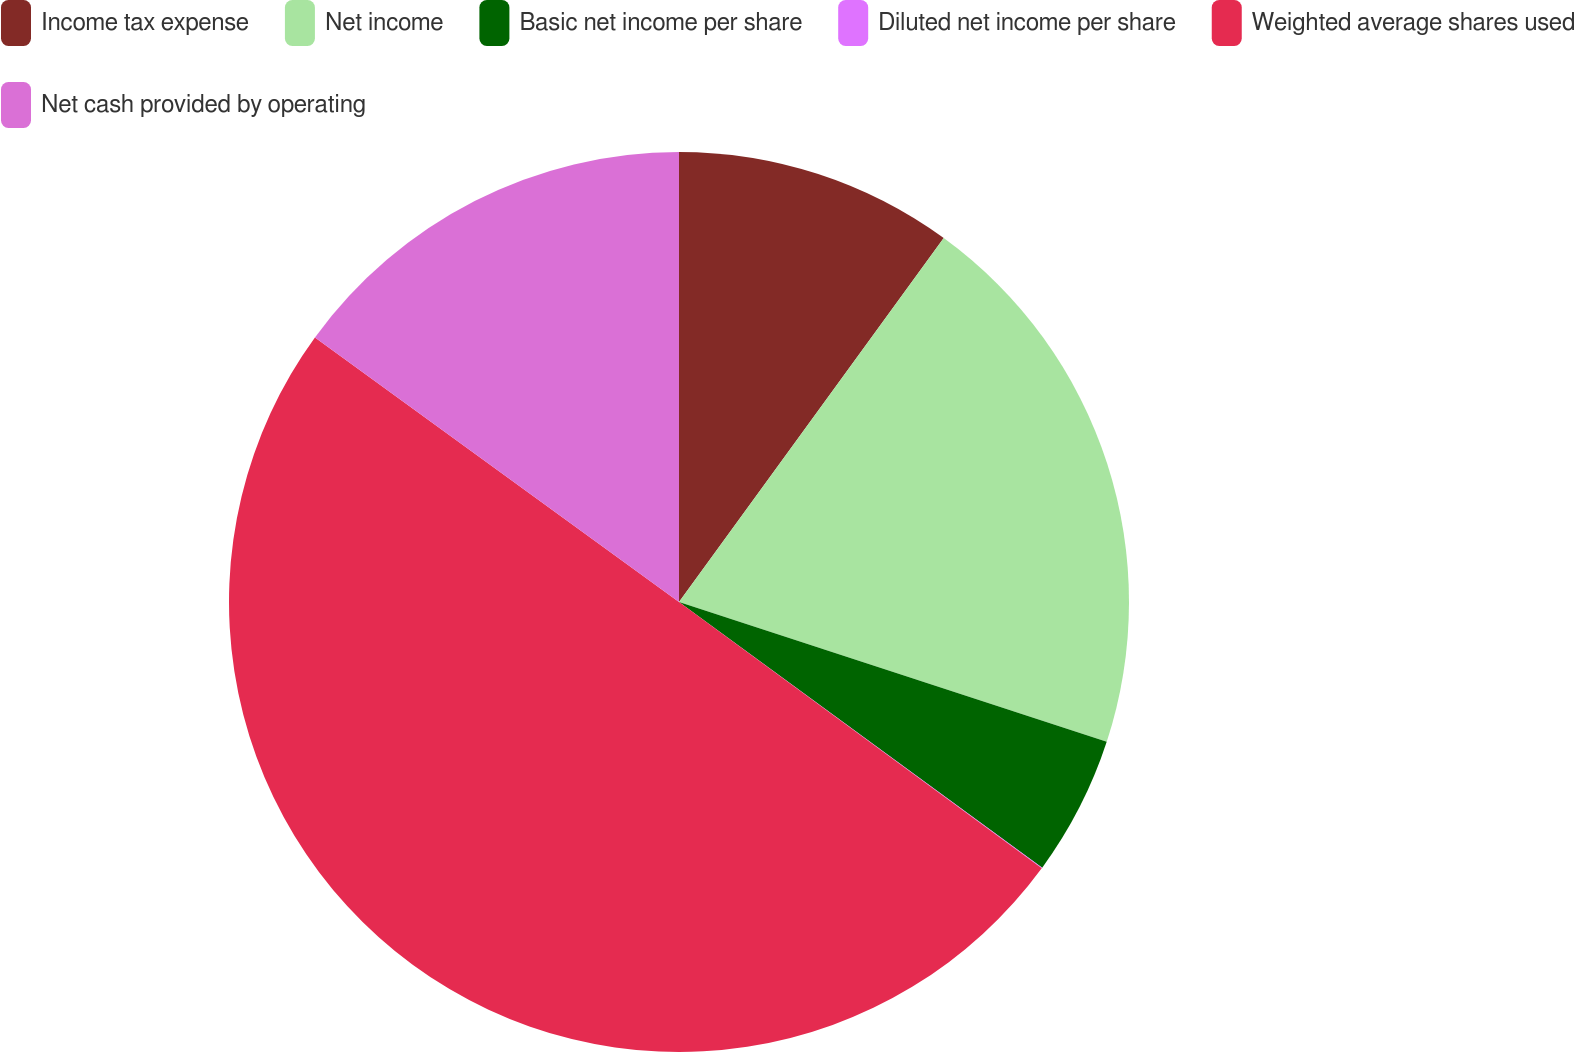Convert chart. <chart><loc_0><loc_0><loc_500><loc_500><pie_chart><fcel>Income tax expense<fcel>Net income<fcel>Basic net income per share<fcel>Diluted net income per share<fcel>Weighted average shares used<fcel>Net cash provided by operating<nl><fcel>10.01%<fcel>20.02%<fcel>5.02%<fcel>0.03%<fcel>49.92%<fcel>15.0%<nl></chart> 